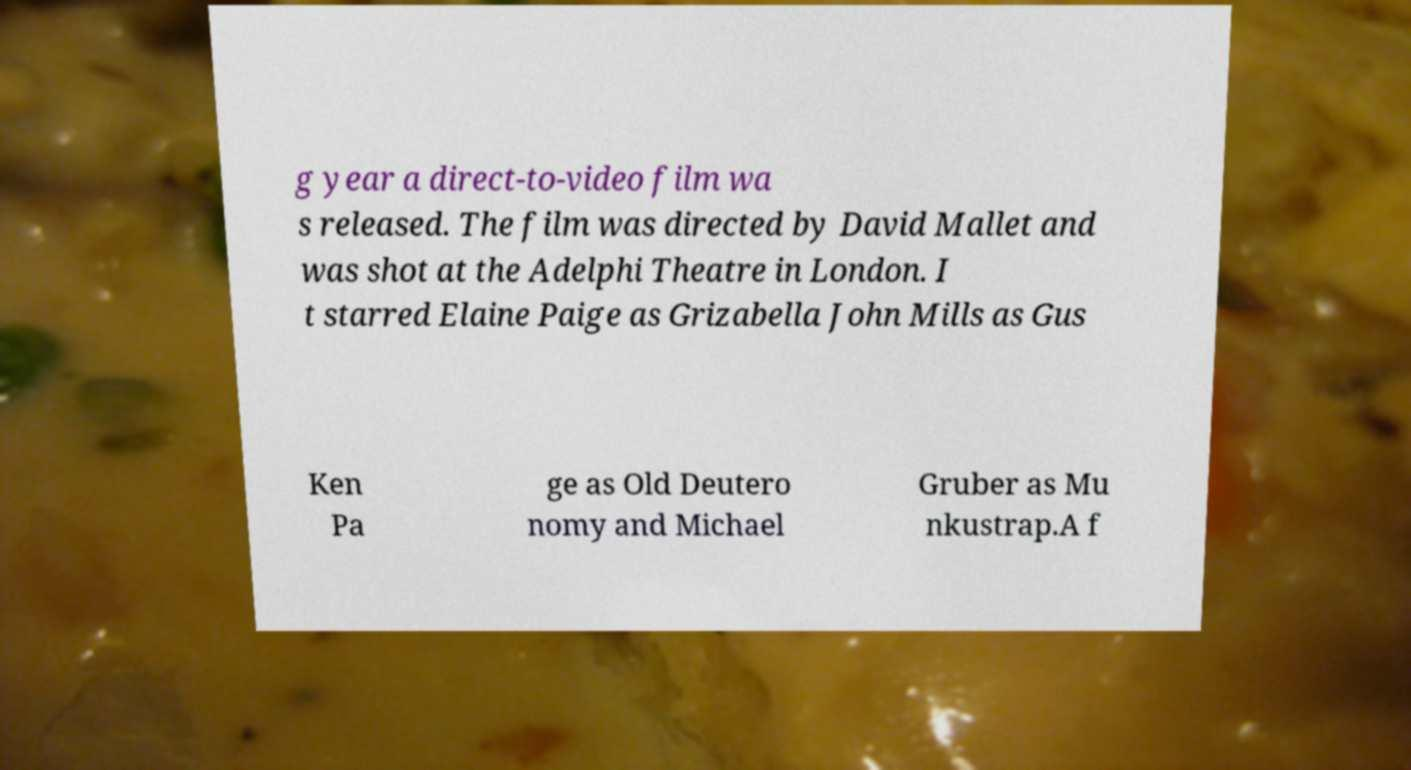There's text embedded in this image that I need extracted. Can you transcribe it verbatim? g year a direct-to-video film wa s released. The film was directed by David Mallet and was shot at the Adelphi Theatre in London. I t starred Elaine Paige as Grizabella John Mills as Gus Ken Pa ge as Old Deutero nomy and Michael Gruber as Mu nkustrap.A f 